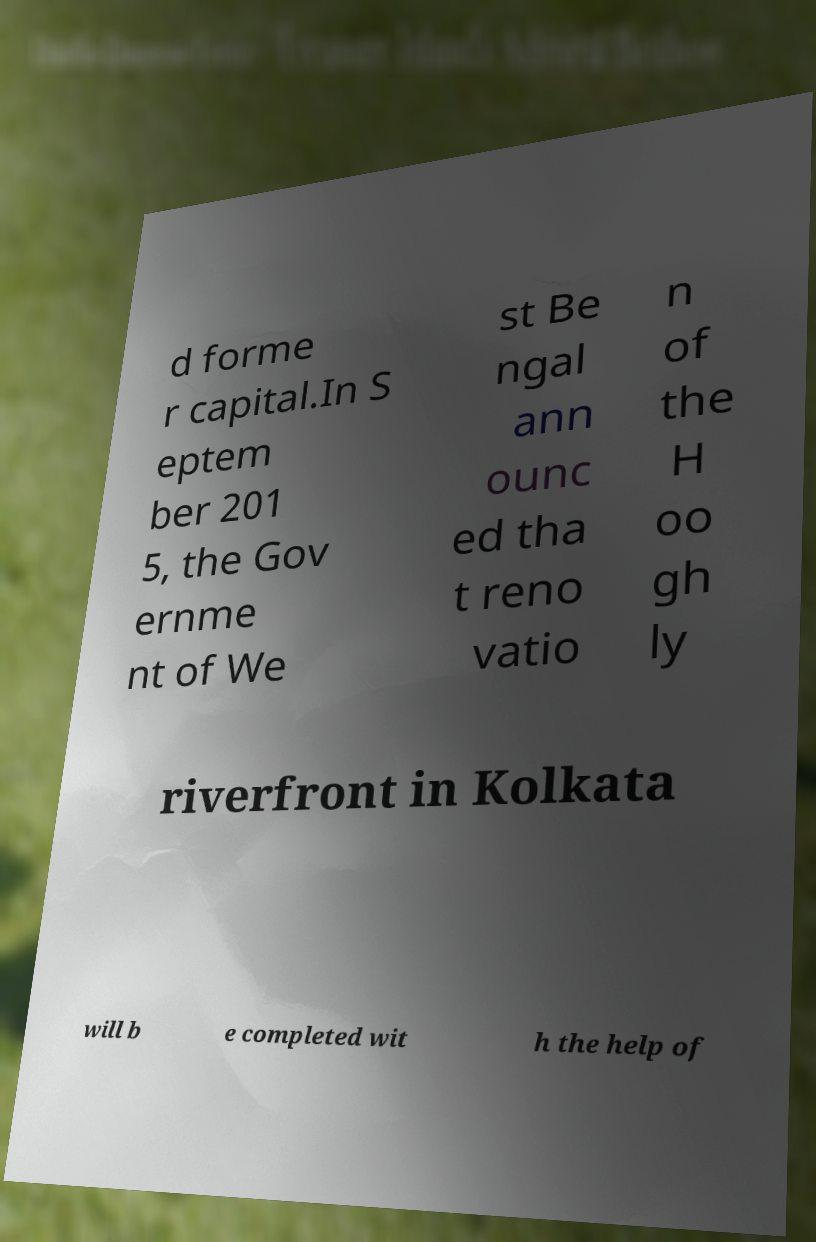Please identify and transcribe the text found in this image. d forme r capital.In S eptem ber 201 5, the Gov ernme nt of We st Be ngal ann ounc ed tha t reno vatio n of the H oo gh ly riverfront in Kolkata will b e completed wit h the help of 